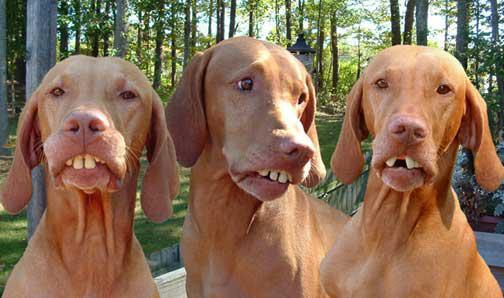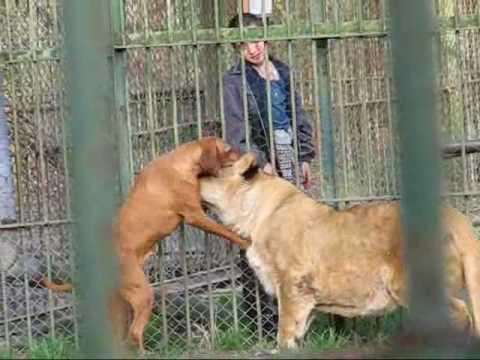The first image is the image on the left, the second image is the image on the right. Given the left and right images, does the statement "There are 3 dogs in one of the images and only 1 dog in the other image." hold true? Answer yes or no. No. The first image is the image on the left, the second image is the image on the right. Examine the images to the left and right. Is the description "The combined images include three dogs posed in a row with their heads close together and at least two the same color, and a metal fence by a red-orange dog." accurate? Answer yes or no. Yes. 